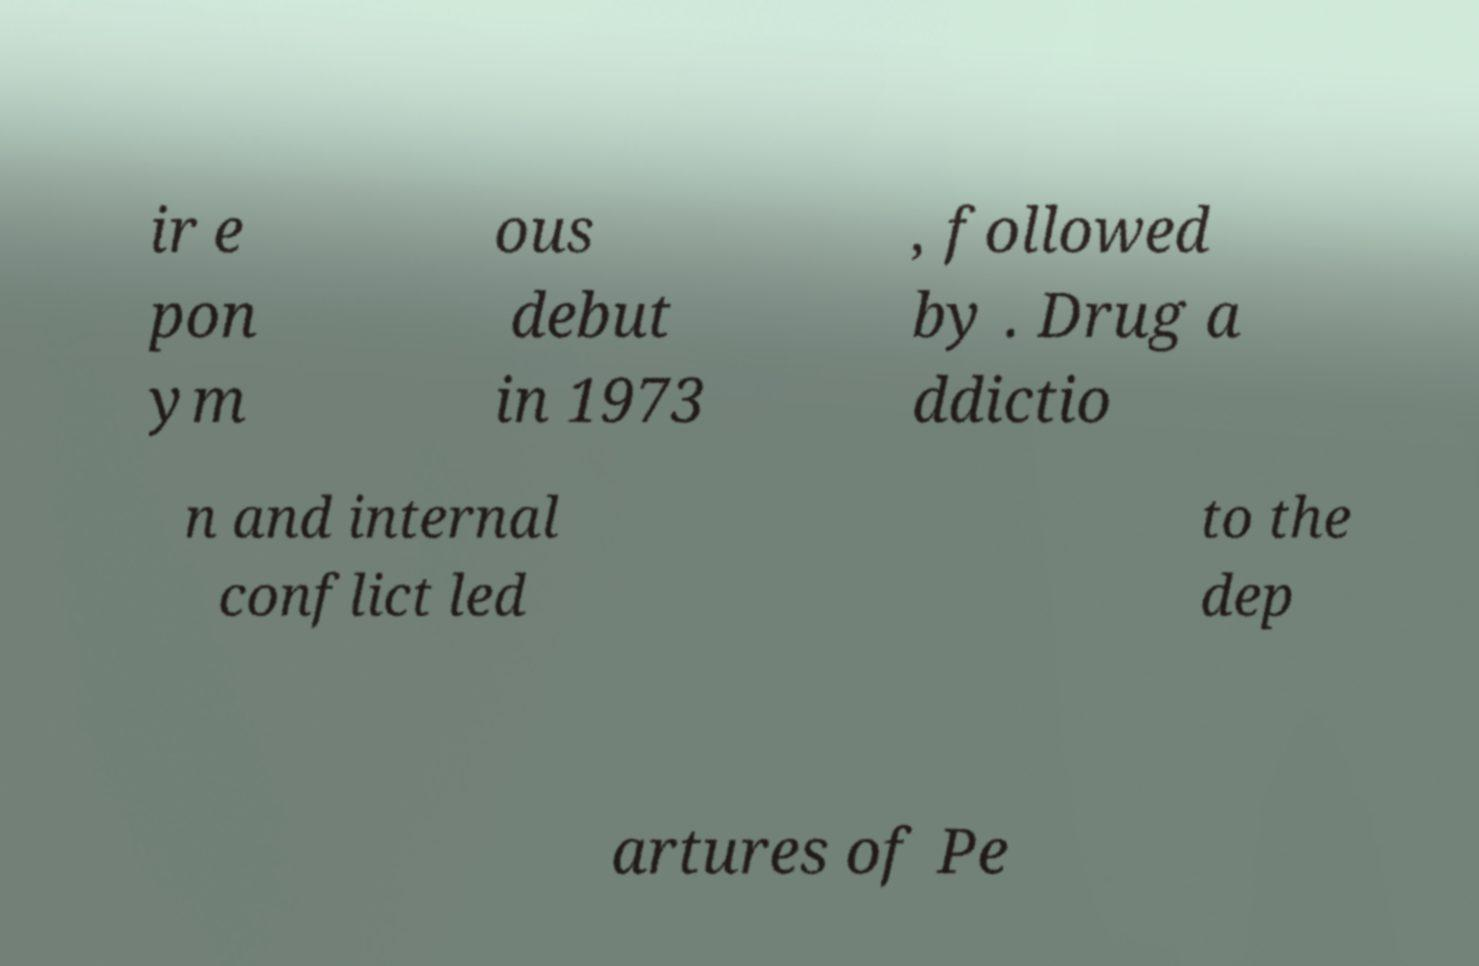There's text embedded in this image that I need extracted. Can you transcribe it verbatim? ir e pon ym ous debut in 1973 , followed by . Drug a ddictio n and internal conflict led to the dep artures of Pe 